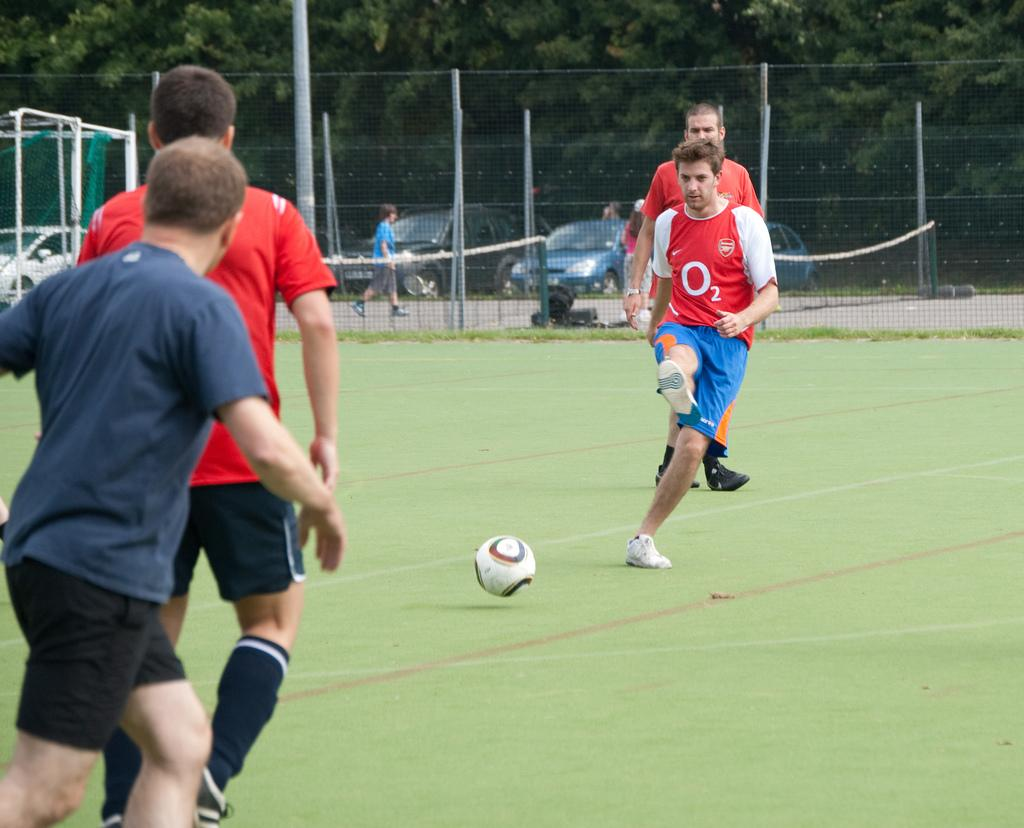What is the main subject in the center of the image? There is a ball in the center of the image. How many persons are in the image, and what are they wearing? There are four persons in different costumes in the image. What can be seen in the background of the image? Trees, vehicles, people, fences, grass, and some objects are visible in the background of the image. Can you tell me how many mothers are visible in the image? There is no mention of a mother or any mothers in the image. Can you see a bat flying in the image? There is no bat visible in the image. 